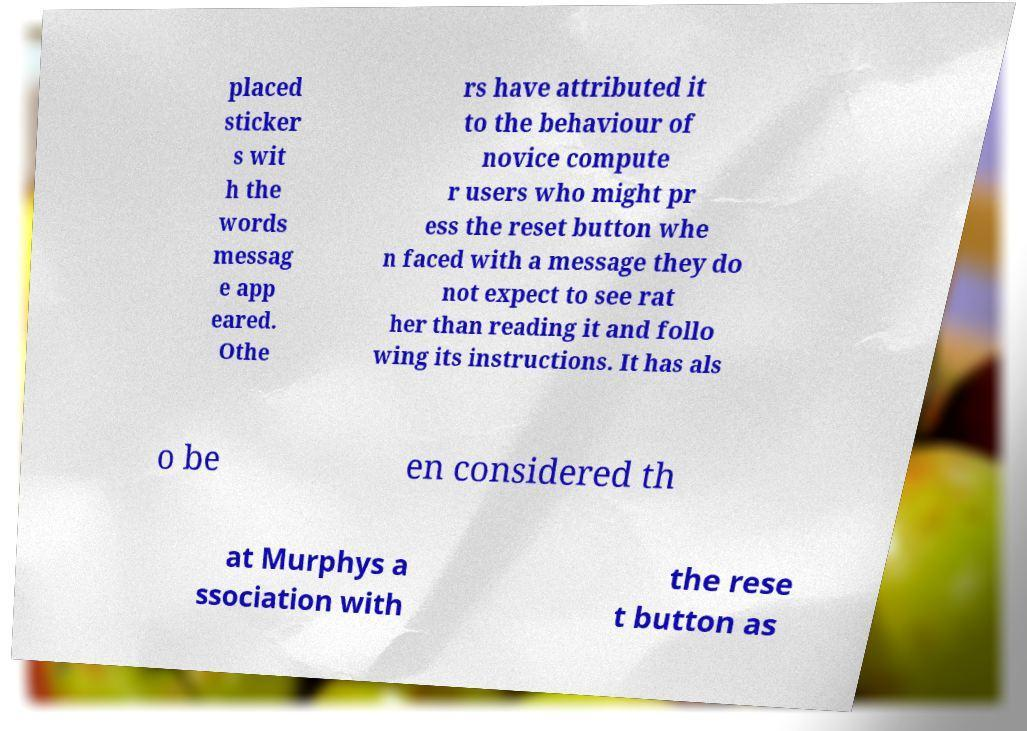Can you read and provide the text displayed in the image?This photo seems to have some interesting text. Can you extract and type it out for me? placed sticker s wit h the words messag e app eared. Othe rs have attributed it to the behaviour of novice compute r users who might pr ess the reset button whe n faced with a message they do not expect to see rat her than reading it and follo wing its instructions. It has als o be en considered th at Murphys a ssociation with the rese t button as 